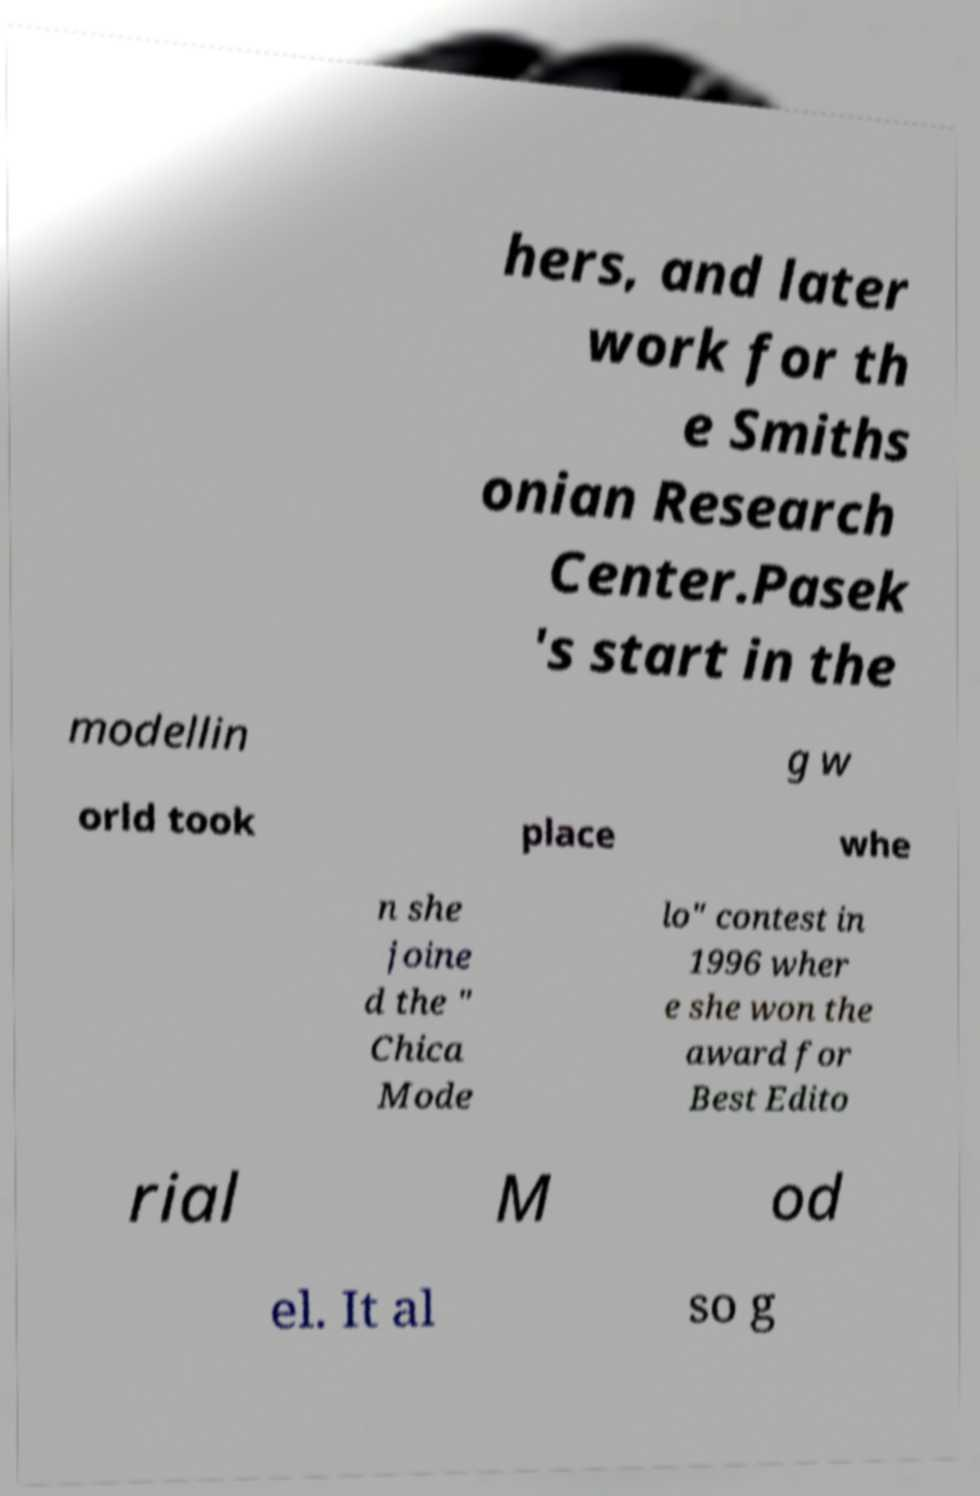I need the written content from this picture converted into text. Can you do that? hers, and later work for th e Smiths onian Research Center.Pasek 's start in the modellin g w orld took place whe n she joine d the " Chica Mode lo" contest in 1996 wher e she won the award for Best Edito rial M od el. It al so g 